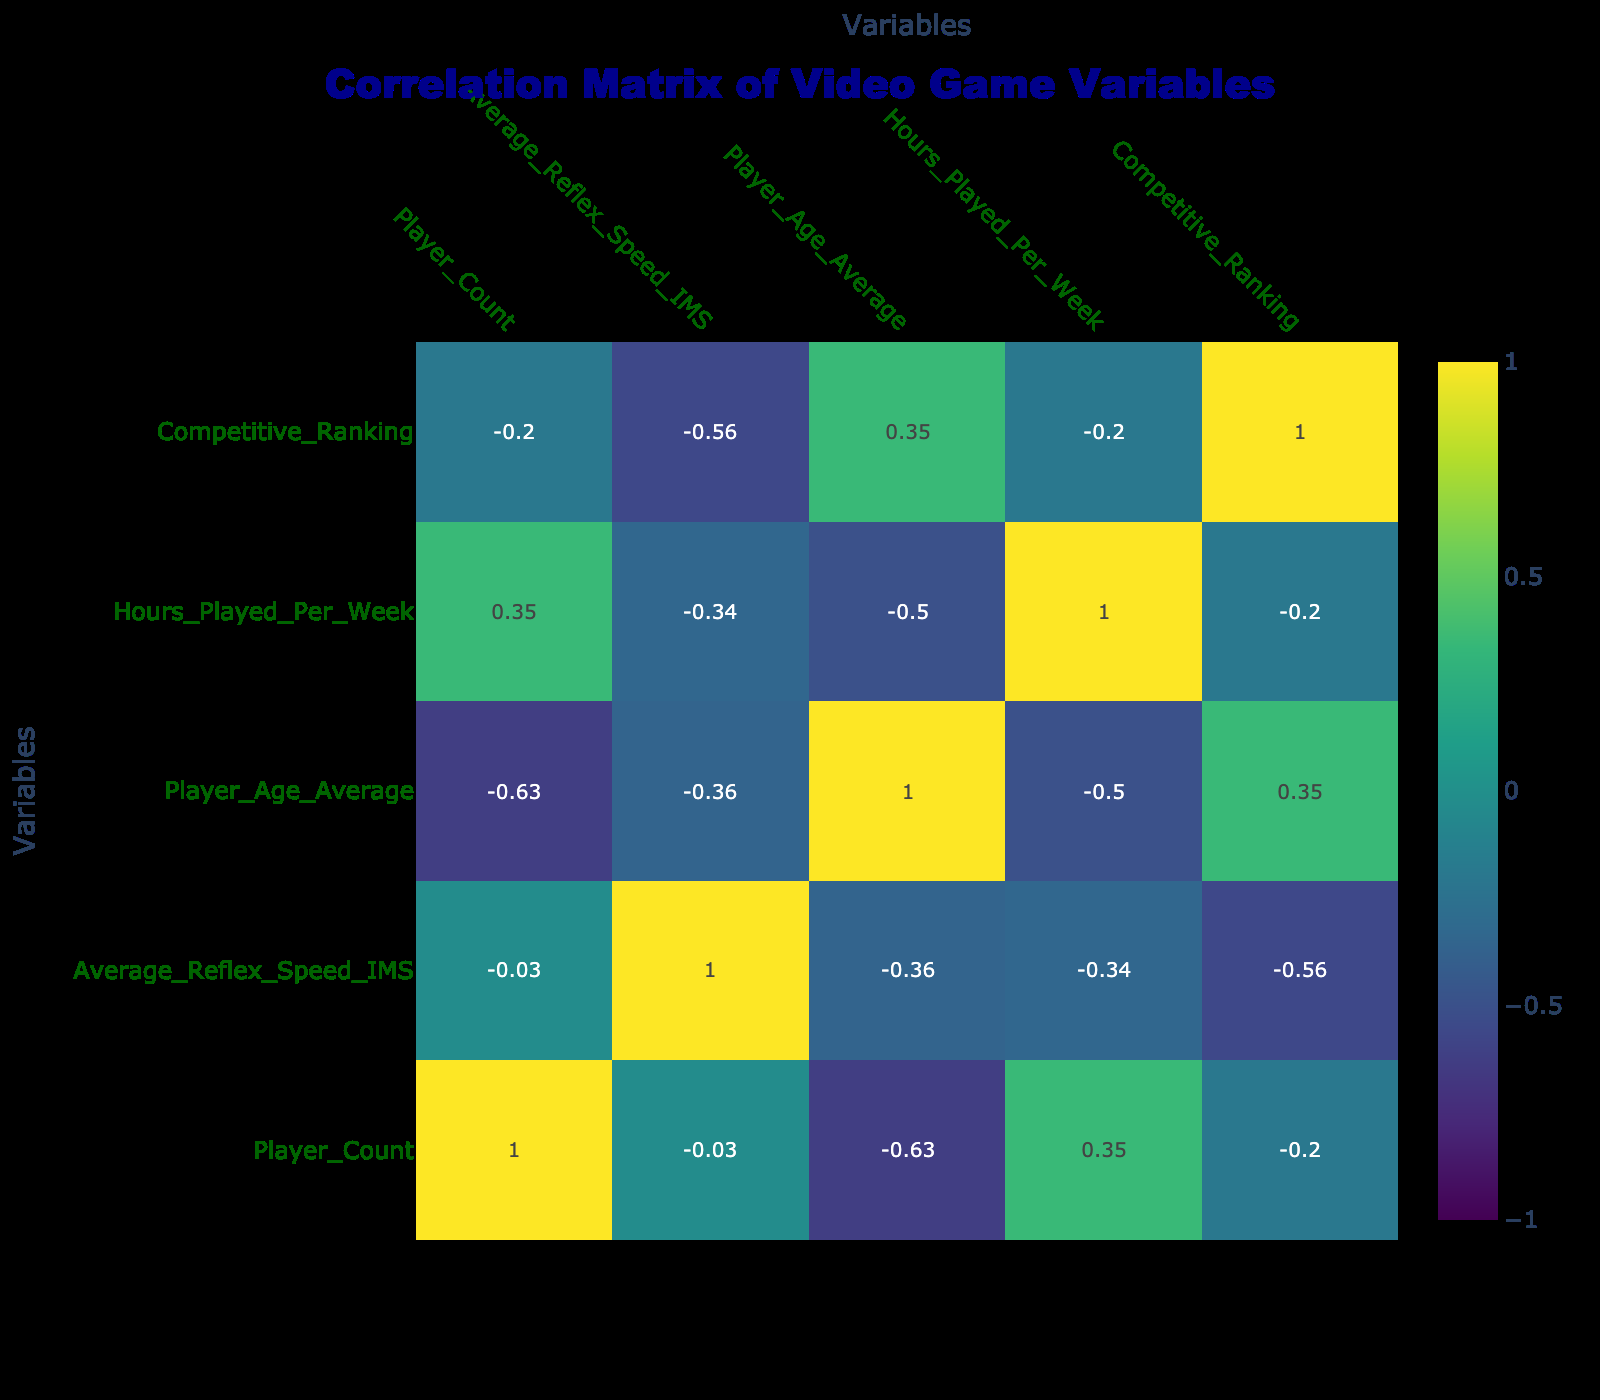What is the average reflex speed in "Dota 2"? The reflex speed for "Dota 2" is listed as 220. There is only one entry for this game, so the average is simply 220.
Answer: 220 What game has the highest average reflex speed? The game with the highest average reflex speed is "Tekken 7," which has a speed of 230.
Answer: 230 Is there a negative correlation between Player Age Average and Average Reflex Speed? The correlation value between Player Age Average and Average Reflex Speed is -0.67, indicating a strong negative correlation. This suggests that as player age increases, reflex speed tends to decrease.
Answer: Yes What is the total number of players across all the games? The total number of players can be calculated by summing the Player_Count for each game: 10 + 12 + 15 + 14 + 13 + 11 + 9 + 8 + 7 + 10 =  119.
Answer: 119 Which game has the lowest competitive ranking and what is its average reflex speed? The game with the lowest competitive ranking of 4 is "Rainbow Six Siege," which has an average reflex speed of 180.
Answer: Rainbow Six Siege, 180 What is the average reflex speed of games with a competitive ranking of 1? The games with a competitive ranking of 1 are "Dota 2," "Counter-Strike: Global Offensive," "League of Legends," and "Rocket League." Their reflex speeds are 220, 190, 215, and 200 respectively. The average is (220 + 190 + 215 + 200) / 4 = 206.25, which we can round to 206.
Answer: 206 Is the average hours played per week positively correlated with average reflex speed? The correlation coefficient between hours played per week and average reflex speed is 0.45, suggesting a moderate positive correlation. This indicates that players who play more hours tend to have higher reflex speeds, although the correlation is not very strong.
Answer: Yes What is the average Player Age for games with a Game Type of "Battle Royale"? The games categorized as "Battle Royale" are "Fortnite," "Apex Legends," and "Call of Duty: Warzone," having average player ages of 20, 22, and 28 respectively. The average player age is calculated as (20 + 22 + 28) / 3 = 23.33, rounded to 23.
Answer: 23 Which game has the highest hours played per week and what is its reflex speed? The game with the highest hours played per week is "Rocket League" at 30 hours. Its average reflex speed is 200.
Answer: Rocket League, 200 